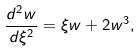<formula> <loc_0><loc_0><loc_500><loc_500>\frac { d ^ { 2 } w } { d \xi ^ { 2 } } = \xi w + 2 w ^ { 3 } ,</formula> 